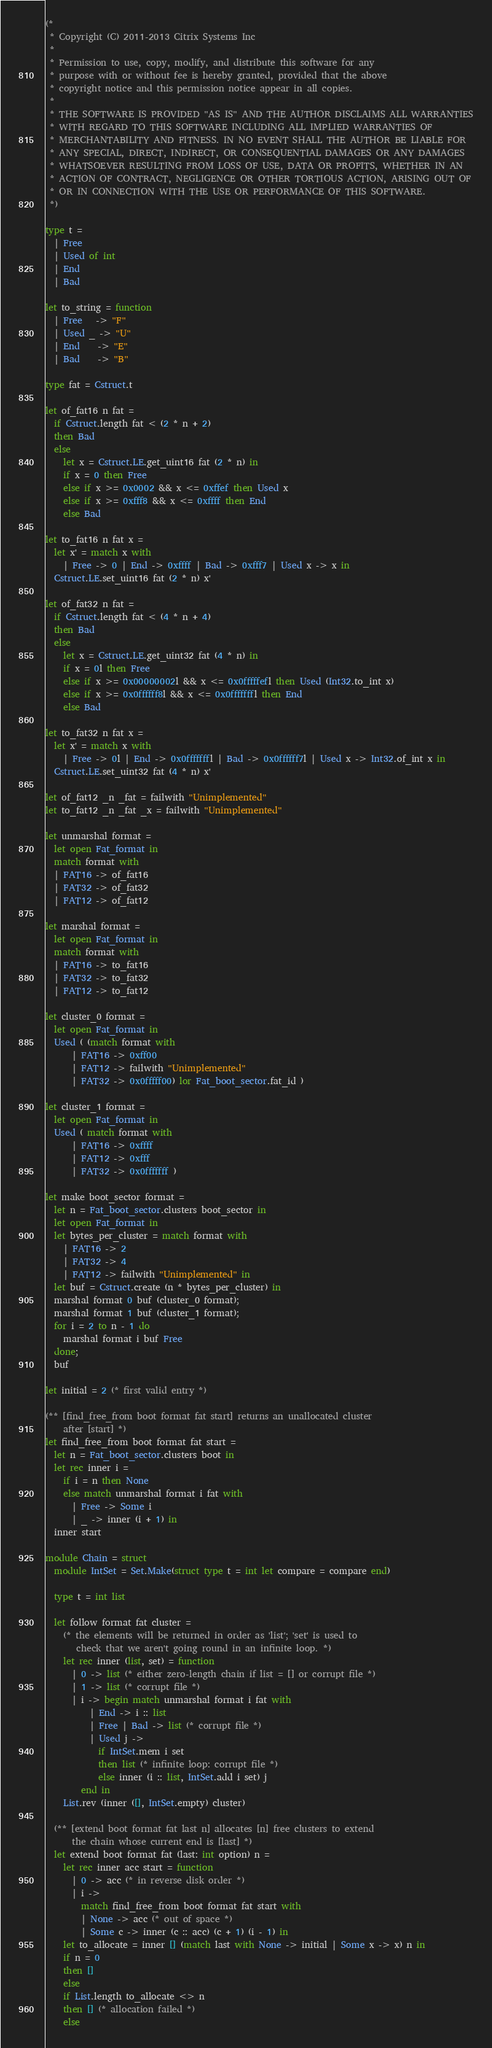<code> <loc_0><loc_0><loc_500><loc_500><_OCaml_>(*
 * Copyright (C) 2011-2013 Citrix Systems Inc
 *
 * Permission to use, copy, modify, and distribute this software for any
 * purpose with or without fee is hereby granted, provided that the above
 * copyright notice and this permission notice appear in all copies.
 *
 * THE SOFTWARE IS PROVIDED "AS IS" AND THE AUTHOR DISCLAIMS ALL WARRANTIES
 * WITH REGARD TO THIS SOFTWARE INCLUDING ALL IMPLIED WARRANTIES OF
 * MERCHANTABILITY AND FITNESS. IN NO EVENT SHALL THE AUTHOR BE LIABLE FOR
 * ANY SPECIAL, DIRECT, INDIRECT, OR CONSEQUENTIAL DAMAGES OR ANY DAMAGES
 * WHATSOEVER RESULTING FROM LOSS OF USE, DATA OR PROFITS, WHETHER IN AN
 * ACTION OF CONTRACT, NEGLIGENCE OR OTHER TORTIOUS ACTION, ARISING OUT OF
 * OR IN CONNECTION WITH THE USE OR PERFORMANCE OF THIS SOFTWARE.
 *)

type t =
  | Free
  | Used of int
  | End
  | Bad

let to_string = function
  | Free   -> "F"
  | Used _ -> "U"
  | End    -> "E"
  | Bad    -> "B"

type fat = Cstruct.t

let of_fat16 n fat =
  if Cstruct.length fat < (2 * n + 2)
  then Bad
  else
    let x = Cstruct.LE.get_uint16 fat (2 * n) in
    if x = 0 then Free
    else if x >= 0x0002 && x <= 0xffef then Used x
    else if x >= 0xfff8 && x <= 0xffff then End
    else Bad

let to_fat16 n fat x =
  let x' = match x with
    | Free -> 0 | End -> 0xffff | Bad -> 0xfff7 | Used x -> x in
  Cstruct.LE.set_uint16 fat (2 * n) x'

let of_fat32 n fat =
  if Cstruct.length fat < (4 * n + 4)
  then Bad
  else
    let x = Cstruct.LE.get_uint32 fat (4 * n) in
    if x = 0l then Free
    else if x >= 0x00000002l && x <= 0x0fffffefl then Used (Int32.to_int x)
    else if x >= 0x0ffffff8l && x <= 0x0fffffffl then End
    else Bad

let to_fat32 n fat x =
  let x' = match x with
    | Free -> 0l | End -> 0x0fffffffl | Bad -> 0x0ffffff7l | Used x -> Int32.of_int x in
  Cstruct.LE.set_uint32 fat (4 * n) x'

let of_fat12 _n _fat = failwith "Unimplemented"
let to_fat12 _n _fat _x = failwith "Unimplemented"

let unmarshal format =
  let open Fat_format in
  match format with
  | FAT16 -> of_fat16
  | FAT32 -> of_fat32
  | FAT12 -> of_fat12

let marshal format =
  let open Fat_format in
  match format with
  | FAT16 -> to_fat16
  | FAT32 -> to_fat32
  | FAT12 -> to_fat12

let cluster_0 format =
  let open Fat_format in
  Used ( (match format with
      | FAT16 -> 0xff00
      | FAT12 -> failwith "Unimplemented"
      | FAT32 -> 0x0fffff00) lor Fat_boot_sector.fat_id )

let cluster_1 format =
  let open Fat_format in
  Used ( match format with
      | FAT16 -> 0xffff
      | FAT12 -> 0xfff
      | FAT32 -> 0x0fffffff )

let make boot_sector format =
  let n = Fat_boot_sector.clusters boot_sector in
  let open Fat_format in
  let bytes_per_cluster = match format with
    | FAT16 -> 2
    | FAT32 -> 4
    | FAT12 -> failwith "Unimplemented" in
  let buf = Cstruct.create (n * bytes_per_cluster) in
  marshal format 0 buf (cluster_0 format);
  marshal format 1 buf (cluster_1 format);
  for i = 2 to n - 1 do
    marshal format i buf Free
  done;
  buf

let initial = 2 (* first valid entry *)

(** [find_free_from boot format fat start] returns an unallocated cluster
    after [start] *)
let find_free_from boot format fat start =
  let n = Fat_boot_sector.clusters boot in
  let rec inner i =
    if i = n then None
    else match unmarshal format i fat with
      | Free -> Some i
      | _ -> inner (i + 1) in
  inner start

module Chain = struct
  module IntSet = Set.Make(struct type t = int let compare = compare end)

  type t = int list

  let follow format fat cluster =
    (* the elements will be returned in order as 'list'; 'set' is used to
       check that we aren't going round in an infinite loop. *)
    let rec inner (list, set) = function
      | 0 -> list (* either zero-length chain if list = [] or corrupt file *)
      | 1 -> list (* corrupt file *)
      | i -> begin match unmarshal format i fat with
          | End -> i :: list
          | Free | Bad -> list (* corrupt file *)
          | Used j ->
            if IntSet.mem i set
            then list (* infinite loop: corrupt file *)
            else inner (i :: list, IntSet.add i set) j
        end in
    List.rev (inner ([], IntSet.empty) cluster)

  (** [extend boot format fat last n] allocates [n] free clusters to extend
      the chain whose current end is [last] *)
  let extend boot format fat (last: int option) n =
    let rec inner acc start = function
      | 0 -> acc (* in reverse disk order *)
      | i ->
        match find_free_from boot format fat start with
        | None -> acc (* out of space *)
        | Some c -> inner (c :: acc) (c + 1) (i - 1) in
    let to_allocate = inner [] (match last with None -> initial | Some x -> x) n in
    if n = 0
    then []
    else
    if List.length to_allocate <> n
    then [] (* allocation failed *)
    else</code> 